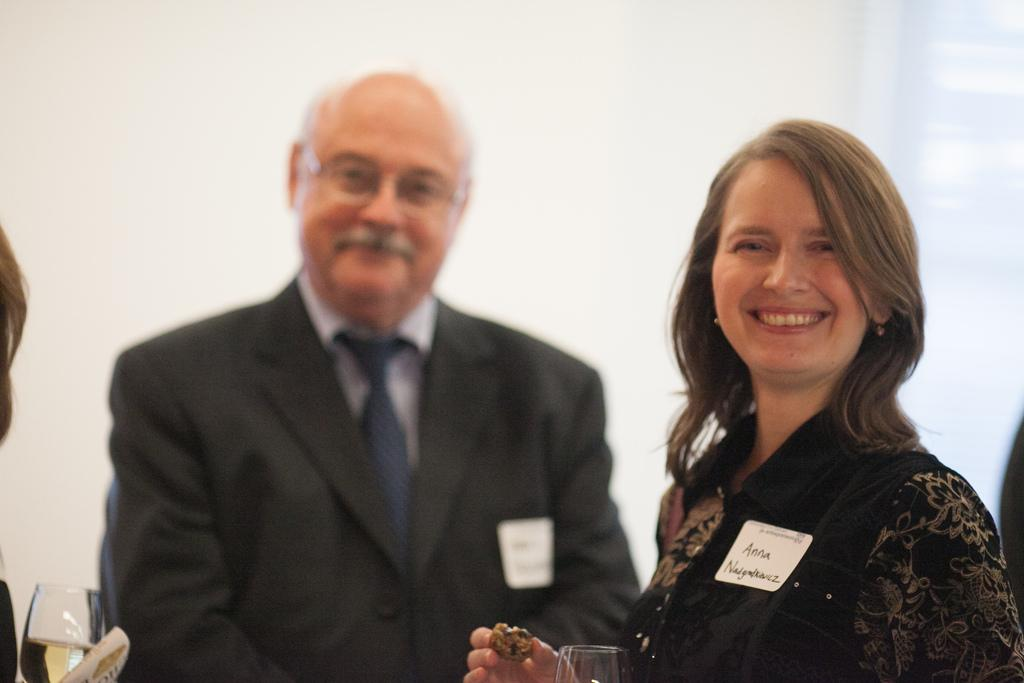How many people are in the image? There are two people in the image, a man and a woman. What are the man and woman doing in the image? The man and woman are standing together. What expressions do the man and woman have in the image? Both the man and woman are smiling. What is the woman holding in the image? The woman is holding a cookie and a glass. What type of furniture can be seen in the image? There is no furniture present in the image. Who is the stranger standing next to the woman in the image? There is no stranger present in the image; the man and woman are together. 